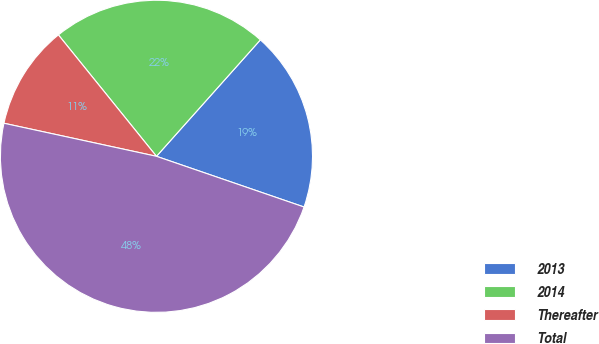Convert chart. <chart><loc_0><loc_0><loc_500><loc_500><pie_chart><fcel>2013<fcel>2014<fcel>Thereafter<fcel>Total<nl><fcel>18.67%<fcel>22.41%<fcel>10.79%<fcel>48.13%<nl></chart> 